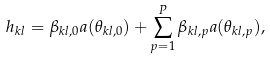Convert formula to latex. <formula><loc_0><loc_0><loc_500><loc_500>h _ { k l } = \beta _ { k l , 0 } a ( \theta _ { k l , 0 } ) + \sum _ { p = 1 } ^ { P } \beta _ { k l , p } a ( \theta _ { k l , p } ) ,</formula> 